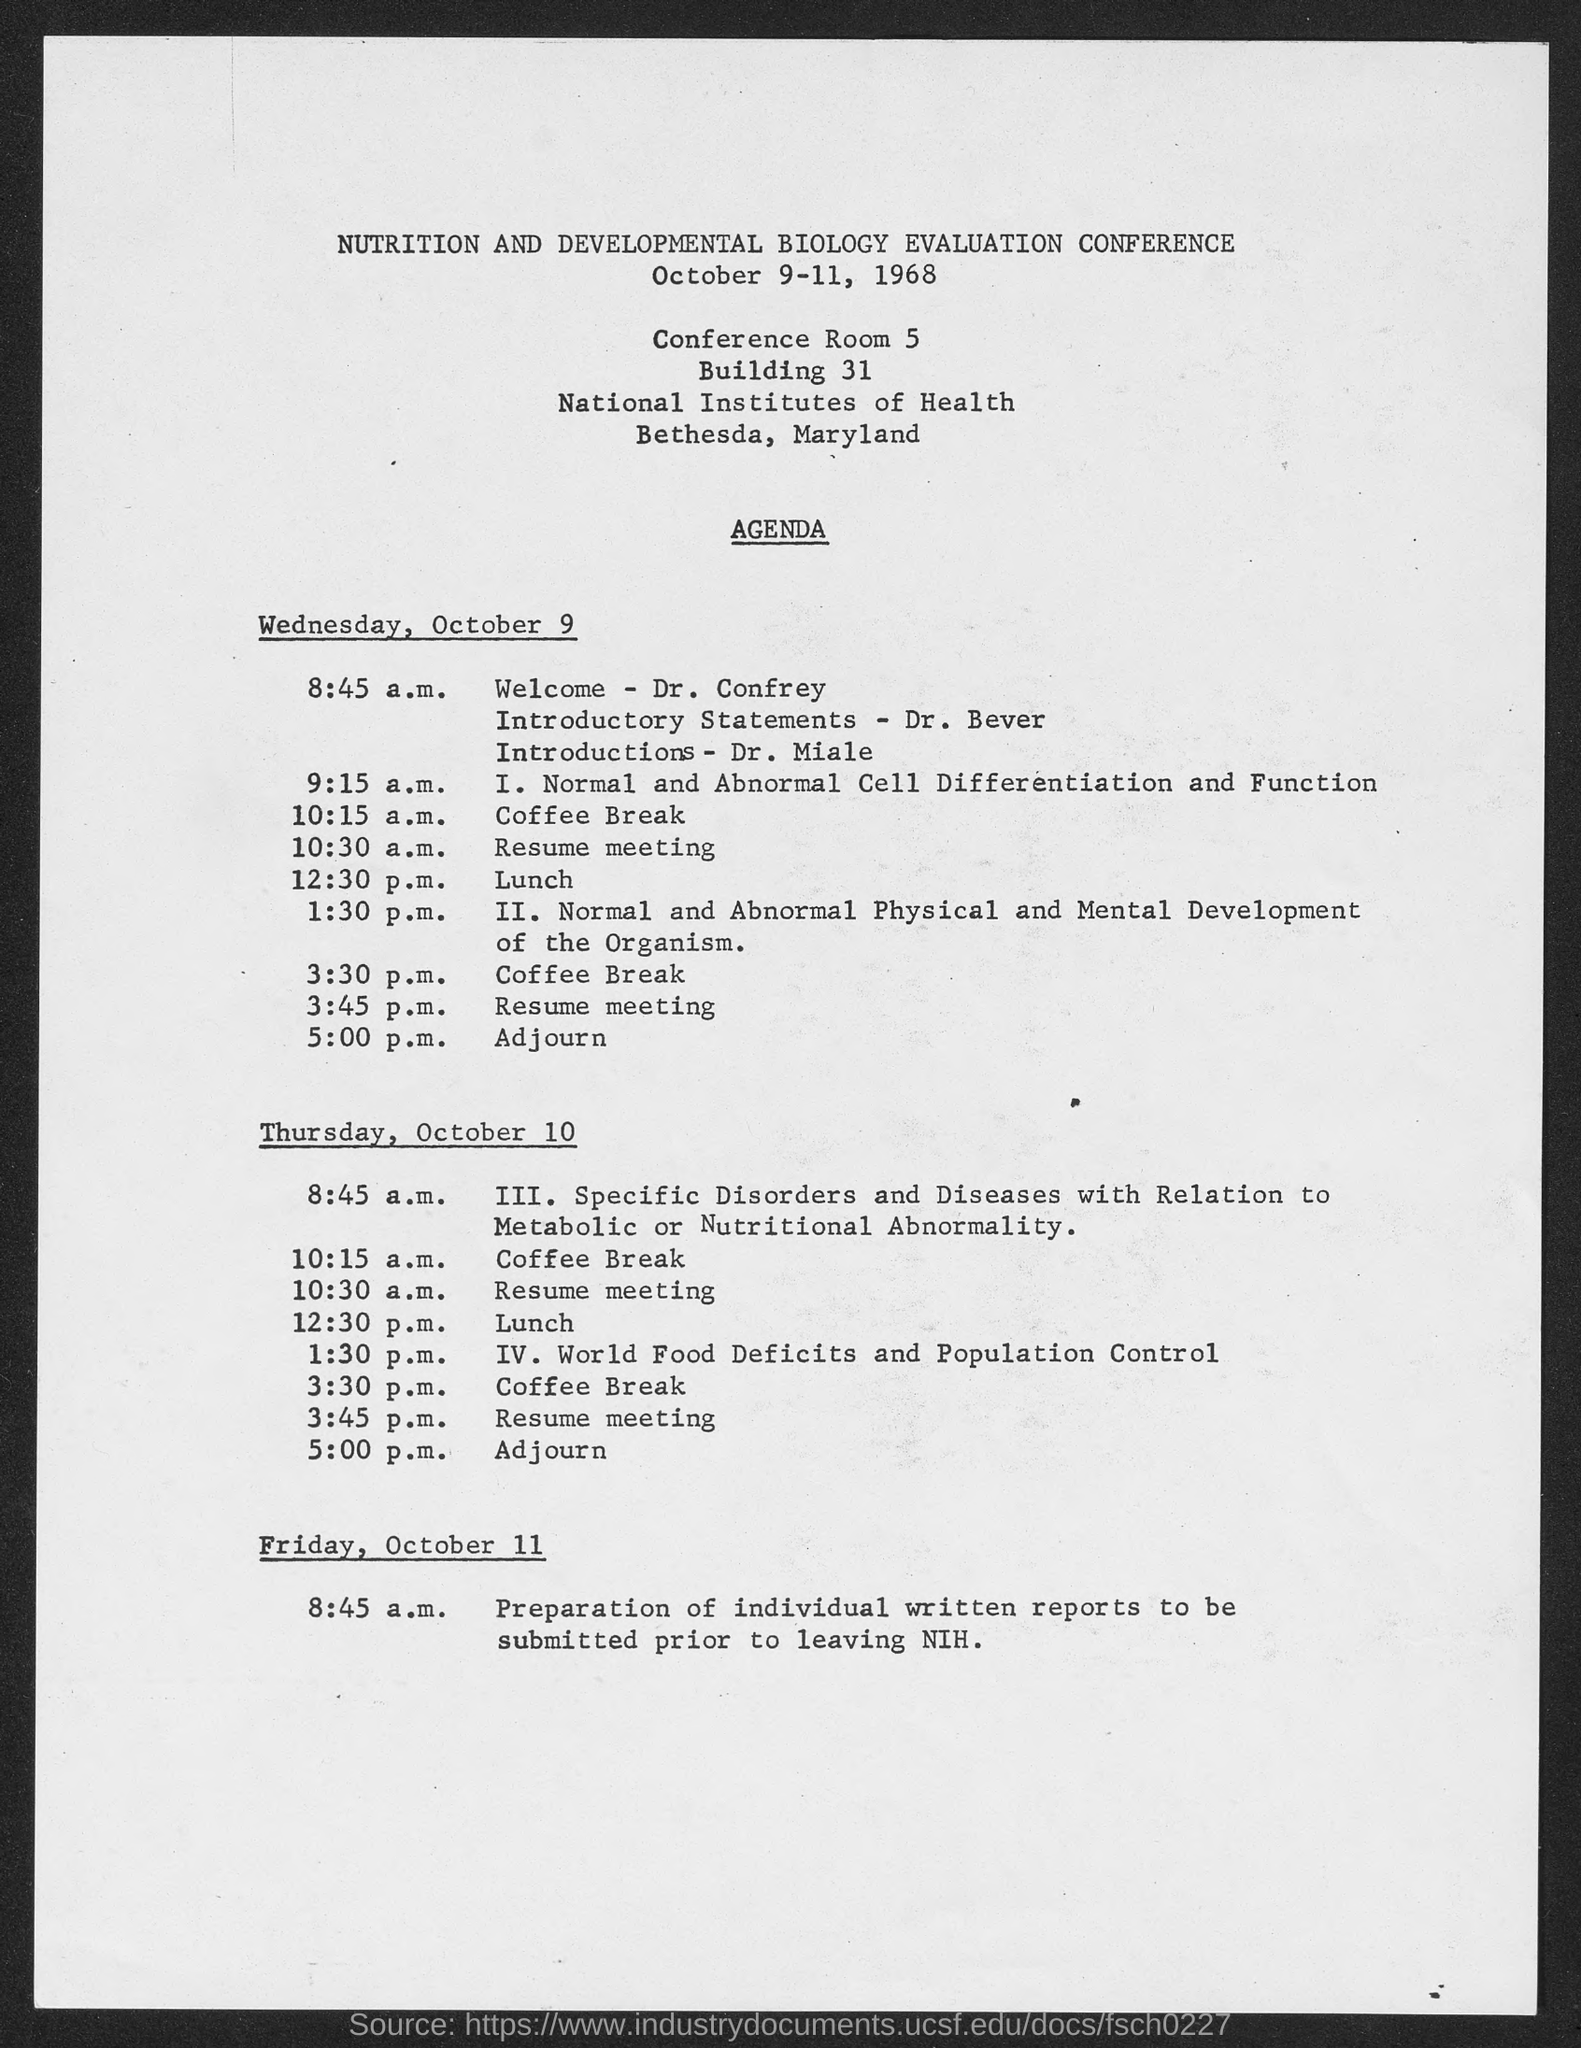What is title of conference?
Your answer should be very brief. Nutrition and Development Biology Evaluation Conference. Who gives welcome speech on Wednesday, October 9?
Provide a succinct answer. DR. CONFREY. When is the lunch on wednesday, october 9?
Provide a succinct answer. 12:30 p.m. Who gave introductory statements on wednesday, october 9?
Give a very brief answer. DR. BEVER. Who gave introductions on wednesday, october 9?
Provide a succinct answer. Dr. Miale. What is the year in which this conference is held?
Provide a succinct answer. 1968. In which month of the year is this conference held in?
Offer a very short reply. October. 